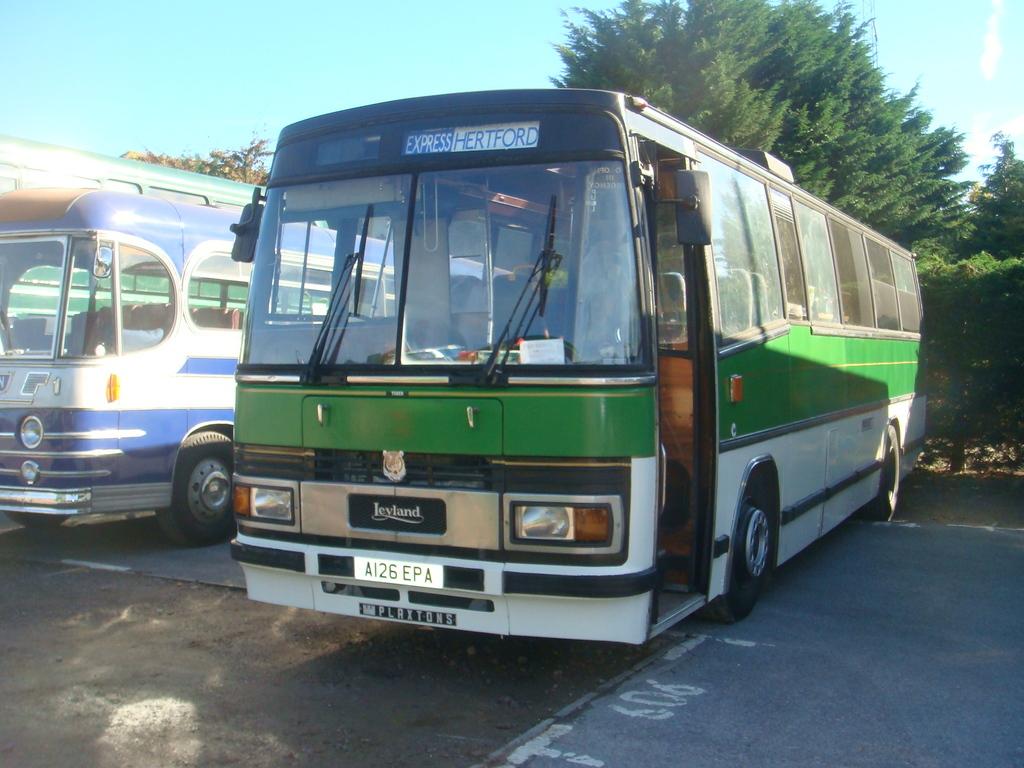Is that a school bus?
Ensure brevity in your answer.  No. What is the liscense number?
Your response must be concise. Ai26 epa. 